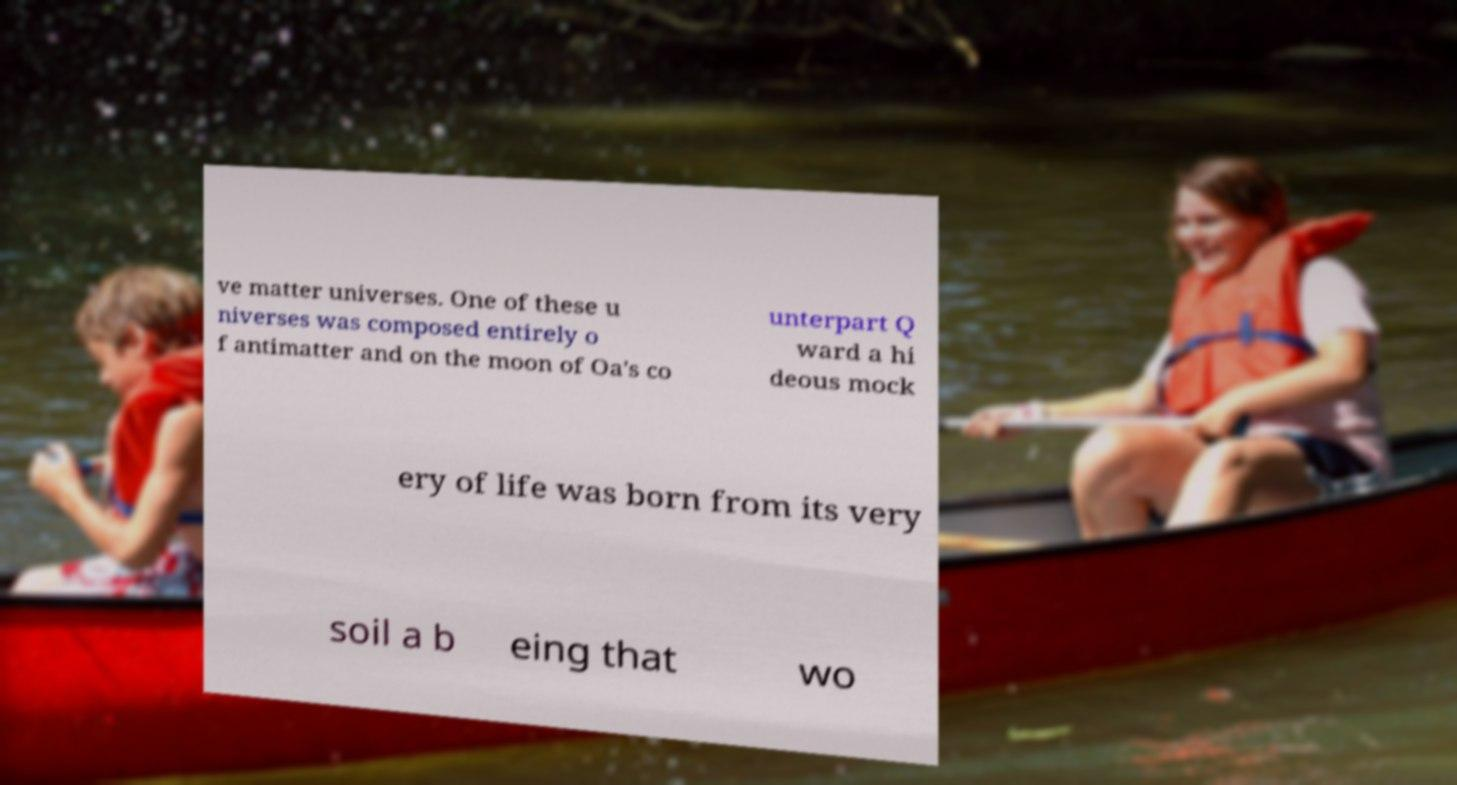There's text embedded in this image that I need extracted. Can you transcribe it verbatim? ve matter universes. One of these u niverses was composed entirely o f antimatter and on the moon of Oa's co unterpart Q ward a hi deous mock ery of life was born from its very soil a b eing that wo 